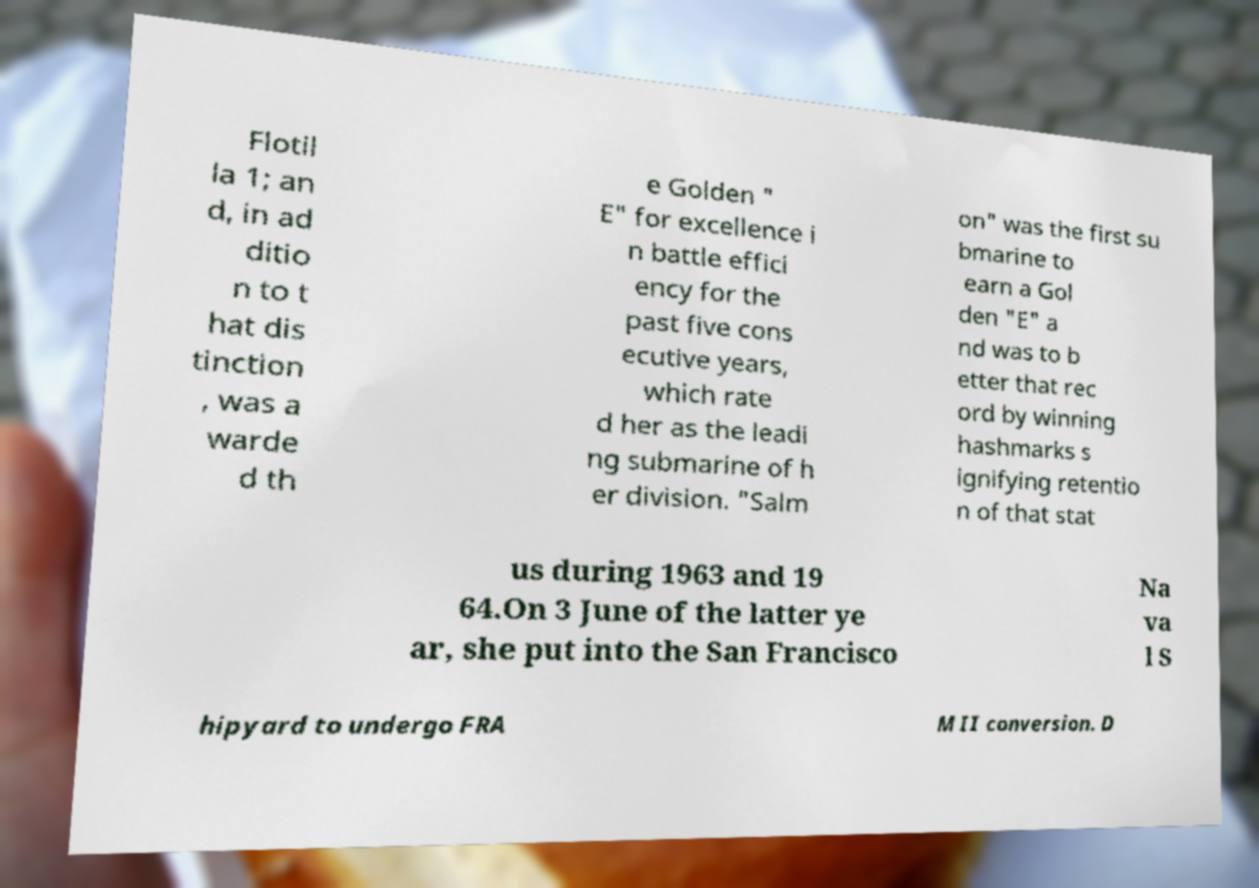For documentation purposes, I need the text within this image transcribed. Could you provide that? Flotil la 1; an d, in ad ditio n to t hat dis tinction , was a warde d th e Golden " E" for excellence i n battle effici ency for the past five cons ecutive years, which rate d her as the leadi ng submarine of h er division. "Salm on" was the first su bmarine to earn a Gol den "E" a nd was to b etter that rec ord by winning hashmarks s ignifying retentio n of that stat us during 1963 and 19 64.On 3 June of the latter ye ar, she put into the San Francisco Na va l S hipyard to undergo FRA M II conversion. D 